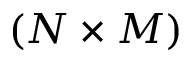Convert formula to latex. <formula><loc_0><loc_0><loc_500><loc_500>( N \times M )</formula> 